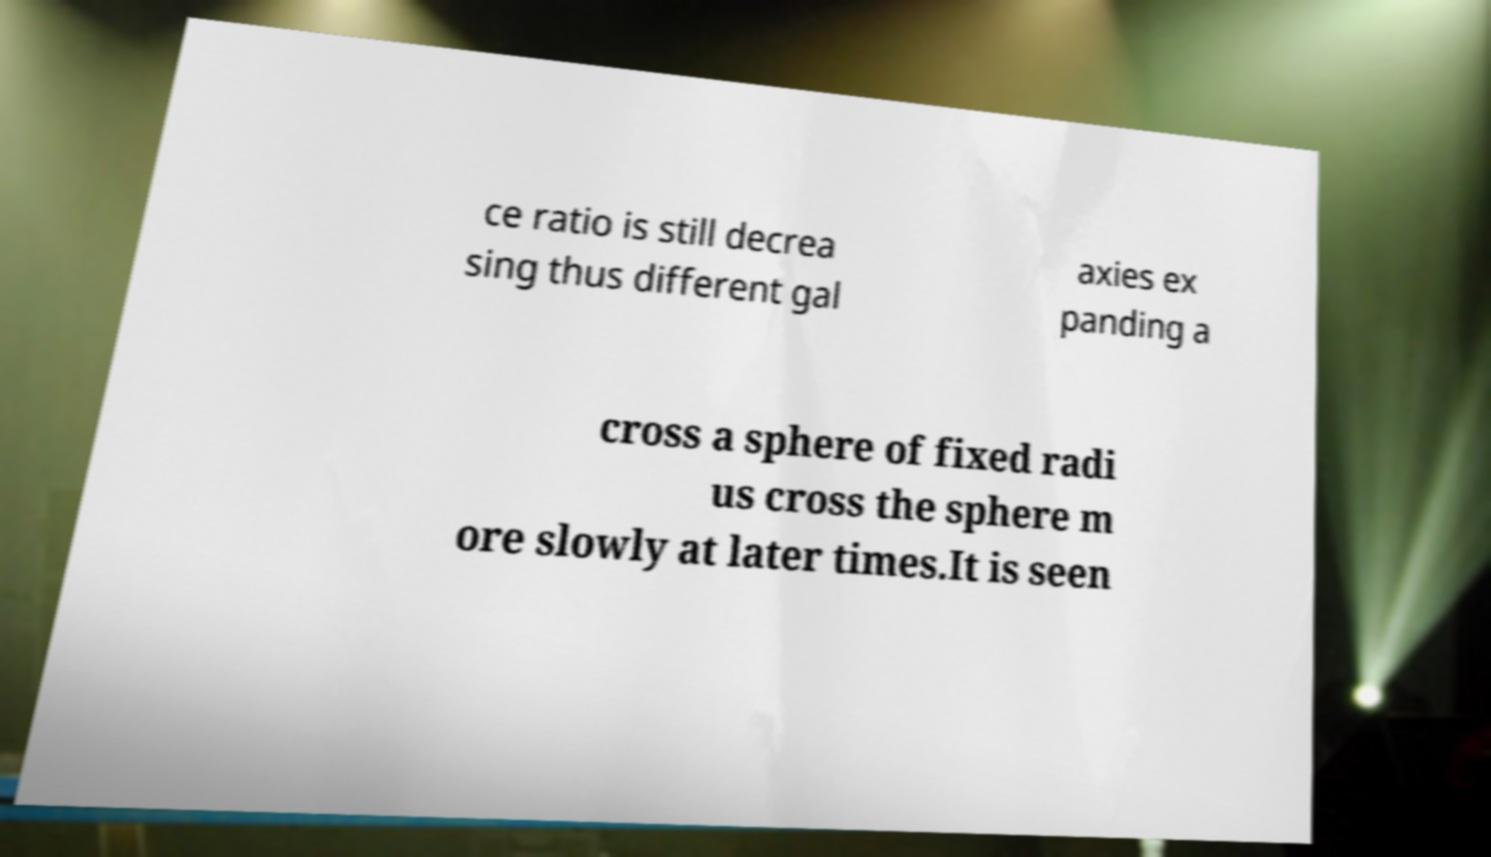Can you accurately transcribe the text from the provided image for me? ce ratio is still decrea sing thus different gal axies ex panding a cross a sphere of fixed radi us cross the sphere m ore slowly at later times.It is seen 